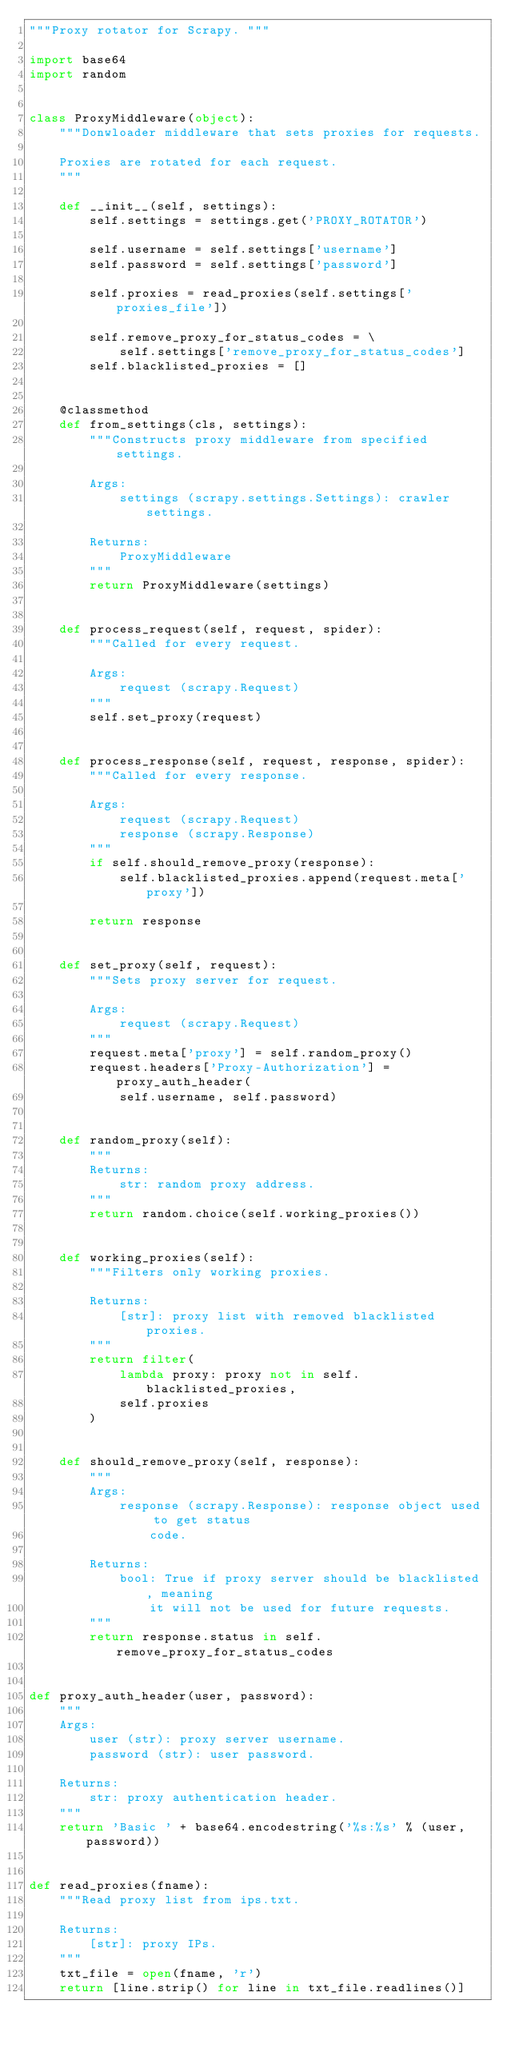Convert code to text. <code><loc_0><loc_0><loc_500><loc_500><_Python_>"""Proxy rotator for Scrapy. """

import base64
import random


class ProxyMiddleware(object):
    """Donwloader middleware that sets proxies for requests.

    Proxies are rotated for each request.
    """

    def __init__(self, settings):
        self.settings = settings.get('PROXY_ROTATOR')

        self.username = self.settings['username']
        self.password = self.settings['password']

        self.proxies = read_proxies(self.settings['proxies_file'])

        self.remove_proxy_for_status_codes = \
            self.settings['remove_proxy_for_status_codes']
        self.blacklisted_proxies = []


    @classmethod
    def from_settings(cls, settings):
        """Constructs proxy middleware from specified settings.

        Args:
            settings (scrapy.settings.Settings): crawler settings.

        Returns:
            ProxyMiddleware
        """
        return ProxyMiddleware(settings)


    def process_request(self, request, spider):
        """Called for every request.

        Args:
            request (scrapy.Request)
        """
        self.set_proxy(request)


    def process_response(self, request, response, spider):
        """Called for every response.

        Args:
            request (scrapy.Request)
            response (scrapy.Response)
        """
        if self.should_remove_proxy(response):
            self.blacklisted_proxies.append(request.meta['proxy'])

        return response


    def set_proxy(self, request):
        """Sets proxy server for request.

        Args:
            request (scrapy.Request)
        """
        request.meta['proxy'] = self.random_proxy()
        request.headers['Proxy-Authorization'] = proxy_auth_header(
            self.username, self.password)


    def random_proxy(self):
        """
        Returns:
            str: random proxy address.
        """
        return random.choice(self.working_proxies())


    def working_proxies(self):
        """Filters only working proxies.

        Returns:
            [str]: proxy list with removed blacklisted proxies.
        """
        return filter(
            lambda proxy: proxy not in self.blacklisted_proxies,
            self.proxies
        )


    def should_remove_proxy(self, response):
        """
        Args:
            response (scrapy.Response): response object used to get status
                code.

        Returns:
            bool: True if proxy server should be blacklisted, meaning
                it will not be used for future requests.
        """
        return response.status in self.remove_proxy_for_status_codes


def proxy_auth_header(user, password):
    """
    Args:
        user (str): proxy server username.
        password (str): user password.

    Returns:
        str: proxy authentication header.
    """
    return 'Basic ' + base64.encodestring('%s:%s' % (user, password))


def read_proxies(fname):
    """Read proxy list from ips.txt.

    Returns:
        [str]: proxy IPs.
    """
    txt_file = open(fname, 'r')
    return [line.strip() for line in txt_file.readlines()]
</code> 